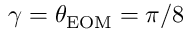<formula> <loc_0><loc_0><loc_500><loc_500>\gamma = \theta _ { E O M } = \pi / 8</formula> 